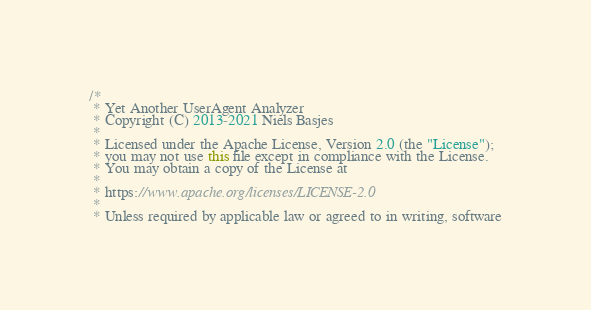Convert code to text. <code><loc_0><loc_0><loc_500><loc_500><_Java_>/*
 * Yet Another UserAgent Analyzer
 * Copyright (C) 2013-2021 Niels Basjes
 *
 * Licensed under the Apache License, Version 2.0 (the "License");
 * you may not use this file except in compliance with the License.
 * You may obtain a copy of the License at
 *
 * https://www.apache.org/licenses/LICENSE-2.0
 *
 * Unless required by applicable law or agreed to in writing, software</code> 